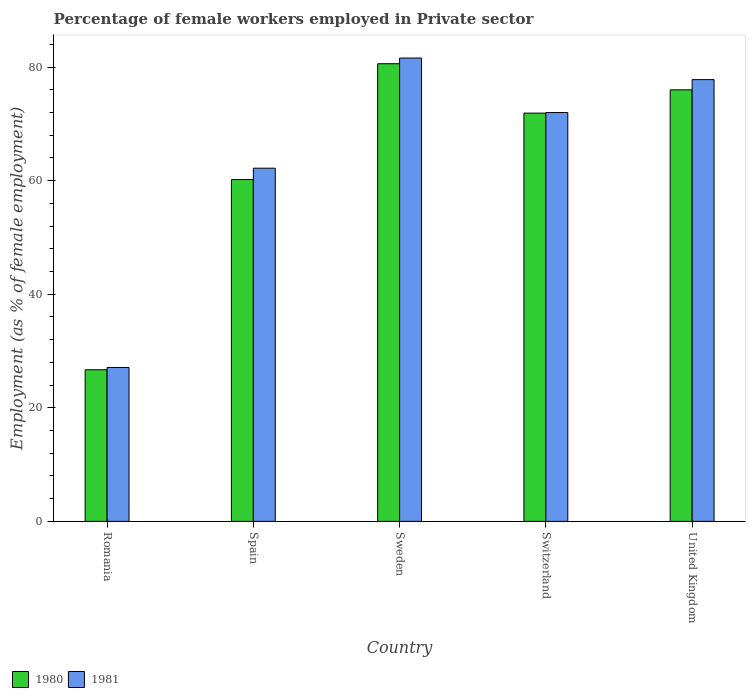How many groups of bars are there?
Offer a very short reply. 5. Are the number of bars on each tick of the X-axis equal?
Give a very brief answer. Yes. What is the label of the 3rd group of bars from the left?
Your answer should be very brief. Sweden. Across all countries, what is the maximum percentage of females employed in Private sector in 1980?
Offer a very short reply. 80.6. Across all countries, what is the minimum percentage of females employed in Private sector in 1980?
Ensure brevity in your answer.  26.7. In which country was the percentage of females employed in Private sector in 1980 minimum?
Offer a very short reply. Romania. What is the total percentage of females employed in Private sector in 1980 in the graph?
Ensure brevity in your answer.  315.4. What is the difference between the percentage of females employed in Private sector in 1980 in Spain and that in United Kingdom?
Ensure brevity in your answer.  -15.8. What is the difference between the percentage of females employed in Private sector in 1980 in Sweden and the percentage of females employed in Private sector in 1981 in Switzerland?
Provide a short and direct response. 8.6. What is the average percentage of females employed in Private sector in 1980 per country?
Your response must be concise. 63.08. What is the difference between the percentage of females employed in Private sector of/in 1981 and percentage of females employed in Private sector of/in 1980 in Switzerland?
Keep it short and to the point. 0.1. What is the ratio of the percentage of females employed in Private sector in 1980 in Sweden to that in United Kingdom?
Provide a short and direct response. 1.06. Is the percentage of females employed in Private sector in 1980 in Romania less than that in Spain?
Your answer should be compact. Yes. Is the difference between the percentage of females employed in Private sector in 1981 in Romania and Switzerland greater than the difference between the percentage of females employed in Private sector in 1980 in Romania and Switzerland?
Your answer should be compact. Yes. What is the difference between the highest and the second highest percentage of females employed in Private sector in 1981?
Make the answer very short. -9.6. What is the difference between the highest and the lowest percentage of females employed in Private sector in 1980?
Your answer should be very brief. 53.9. Is the sum of the percentage of females employed in Private sector in 1981 in Spain and United Kingdom greater than the maximum percentage of females employed in Private sector in 1980 across all countries?
Ensure brevity in your answer.  Yes. What does the 1st bar from the left in Spain represents?
Provide a short and direct response. 1980. What does the 1st bar from the right in Romania represents?
Offer a terse response. 1981. Are all the bars in the graph horizontal?
Your response must be concise. No. Does the graph contain grids?
Ensure brevity in your answer.  No. Where does the legend appear in the graph?
Provide a short and direct response. Bottom left. How are the legend labels stacked?
Offer a very short reply. Horizontal. What is the title of the graph?
Offer a terse response. Percentage of female workers employed in Private sector. What is the label or title of the Y-axis?
Offer a very short reply. Employment (as % of female employment). What is the Employment (as % of female employment) in 1980 in Romania?
Offer a terse response. 26.7. What is the Employment (as % of female employment) in 1981 in Romania?
Your answer should be very brief. 27.1. What is the Employment (as % of female employment) of 1980 in Spain?
Your response must be concise. 60.2. What is the Employment (as % of female employment) in 1981 in Spain?
Keep it short and to the point. 62.2. What is the Employment (as % of female employment) in 1980 in Sweden?
Provide a succinct answer. 80.6. What is the Employment (as % of female employment) in 1981 in Sweden?
Give a very brief answer. 81.6. What is the Employment (as % of female employment) in 1980 in Switzerland?
Your response must be concise. 71.9. What is the Employment (as % of female employment) in 1980 in United Kingdom?
Give a very brief answer. 76. What is the Employment (as % of female employment) of 1981 in United Kingdom?
Give a very brief answer. 77.8. Across all countries, what is the maximum Employment (as % of female employment) in 1980?
Your answer should be compact. 80.6. Across all countries, what is the maximum Employment (as % of female employment) in 1981?
Make the answer very short. 81.6. Across all countries, what is the minimum Employment (as % of female employment) in 1980?
Ensure brevity in your answer.  26.7. Across all countries, what is the minimum Employment (as % of female employment) of 1981?
Offer a very short reply. 27.1. What is the total Employment (as % of female employment) in 1980 in the graph?
Your answer should be compact. 315.4. What is the total Employment (as % of female employment) of 1981 in the graph?
Your answer should be compact. 320.7. What is the difference between the Employment (as % of female employment) of 1980 in Romania and that in Spain?
Keep it short and to the point. -33.5. What is the difference between the Employment (as % of female employment) in 1981 in Romania and that in Spain?
Ensure brevity in your answer.  -35.1. What is the difference between the Employment (as % of female employment) in 1980 in Romania and that in Sweden?
Offer a very short reply. -53.9. What is the difference between the Employment (as % of female employment) of 1981 in Romania and that in Sweden?
Provide a short and direct response. -54.5. What is the difference between the Employment (as % of female employment) of 1980 in Romania and that in Switzerland?
Offer a very short reply. -45.2. What is the difference between the Employment (as % of female employment) of 1981 in Romania and that in Switzerland?
Provide a succinct answer. -44.9. What is the difference between the Employment (as % of female employment) of 1980 in Romania and that in United Kingdom?
Keep it short and to the point. -49.3. What is the difference between the Employment (as % of female employment) in 1981 in Romania and that in United Kingdom?
Make the answer very short. -50.7. What is the difference between the Employment (as % of female employment) of 1980 in Spain and that in Sweden?
Give a very brief answer. -20.4. What is the difference between the Employment (as % of female employment) in 1981 in Spain and that in Sweden?
Your answer should be very brief. -19.4. What is the difference between the Employment (as % of female employment) of 1980 in Spain and that in United Kingdom?
Make the answer very short. -15.8. What is the difference between the Employment (as % of female employment) of 1981 in Spain and that in United Kingdom?
Ensure brevity in your answer.  -15.6. What is the difference between the Employment (as % of female employment) of 1981 in Sweden and that in Switzerland?
Offer a very short reply. 9.6. What is the difference between the Employment (as % of female employment) of 1980 in Sweden and that in United Kingdom?
Offer a very short reply. 4.6. What is the difference between the Employment (as % of female employment) of 1980 in Romania and the Employment (as % of female employment) of 1981 in Spain?
Your answer should be compact. -35.5. What is the difference between the Employment (as % of female employment) of 1980 in Romania and the Employment (as % of female employment) of 1981 in Sweden?
Keep it short and to the point. -54.9. What is the difference between the Employment (as % of female employment) in 1980 in Romania and the Employment (as % of female employment) in 1981 in Switzerland?
Provide a short and direct response. -45.3. What is the difference between the Employment (as % of female employment) of 1980 in Romania and the Employment (as % of female employment) of 1981 in United Kingdom?
Keep it short and to the point. -51.1. What is the difference between the Employment (as % of female employment) of 1980 in Spain and the Employment (as % of female employment) of 1981 in Sweden?
Keep it short and to the point. -21.4. What is the difference between the Employment (as % of female employment) in 1980 in Spain and the Employment (as % of female employment) in 1981 in Switzerland?
Offer a terse response. -11.8. What is the difference between the Employment (as % of female employment) of 1980 in Spain and the Employment (as % of female employment) of 1981 in United Kingdom?
Provide a short and direct response. -17.6. What is the difference between the Employment (as % of female employment) of 1980 in Switzerland and the Employment (as % of female employment) of 1981 in United Kingdom?
Your response must be concise. -5.9. What is the average Employment (as % of female employment) in 1980 per country?
Provide a succinct answer. 63.08. What is the average Employment (as % of female employment) of 1981 per country?
Offer a terse response. 64.14. What is the difference between the Employment (as % of female employment) in 1980 and Employment (as % of female employment) in 1981 in Romania?
Your response must be concise. -0.4. What is the difference between the Employment (as % of female employment) of 1980 and Employment (as % of female employment) of 1981 in Spain?
Make the answer very short. -2. What is the difference between the Employment (as % of female employment) of 1980 and Employment (as % of female employment) of 1981 in Sweden?
Your answer should be compact. -1. What is the difference between the Employment (as % of female employment) of 1980 and Employment (as % of female employment) of 1981 in Switzerland?
Your answer should be compact. -0.1. What is the ratio of the Employment (as % of female employment) in 1980 in Romania to that in Spain?
Offer a terse response. 0.44. What is the ratio of the Employment (as % of female employment) in 1981 in Romania to that in Spain?
Provide a short and direct response. 0.44. What is the ratio of the Employment (as % of female employment) in 1980 in Romania to that in Sweden?
Keep it short and to the point. 0.33. What is the ratio of the Employment (as % of female employment) in 1981 in Romania to that in Sweden?
Offer a very short reply. 0.33. What is the ratio of the Employment (as % of female employment) in 1980 in Romania to that in Switzerland?
Your response must be concise. 0.37. What is the ratio of the Employment (as % of female employment) in 1981 in Romania to that in Switzerland?
Your response must be concise. 0.38. What is the ratio of the Employment (as % of female employment) of 1980 in Romania to that in United Kingdom?
Provide a short and direct response. 0.35. What is the ratio of the Employment (as % of female employment) in 1981 in Romania to that in United Kingdom?
Your answer should be very brief. 0.35. What is the ratio of the Employment (as % of female employment) in 1980 in Spain to that in Sweden?
Your response must be concise. 0.75. What is the ratio of the Employment (as % of female employment) of 1981 in Spain to that in Sweden?
Provide a succinct answer. 0.76. What is the ratio of the Employment (as % of female employment) of 1980 in Spain to that in Switzerland?
Make the answer very short. 0.84. What is the ratio of the Employment (as % of female employment) in 1981 in Spain to that in Switzerland?
Provide a succinct answer. 0.86. What is the ratio of the Employment (as % of female employment) in 1980 in Spain to that in United Kingdom?
Ensure brevity in your answer.  0.79. What is the ratio of the Employment (as % of female employment) of 1981 in Spain to that in United Kingdom?
Give a very brief answer. 0.8. What is the ratio of the Employment (as % of female employment) in 1980 in Sweden to that in Switzerland?
Give a very brief answer. 1.12. What is the ratio of the Employment (as % of female employment) in 1981 in Sweden to that in Switzerland?
Your answer should be compact. 1.13. What is the ratio of the Employment (as % of female employment) of 1980 in Sweden to that in United Kingdom?
Your answer should be compact. 1.06. What is the ratio of the Employment (as % of female employment) in 1981 in Sweden to that in United Kingdom?
Make the answer very short. 1.05. What is the ratio of the Employment (as % of female employment) in 1980 in Switzerland to that in United Kingdom?
Make the answer very short. 0.95. What is the ratio of the Employment (as % of female employment) of 1981 in Switzerland to that in United Kingdom?
Provide a short and direct response. 0.93. What is the difference between the highest and the lowest Employment (as % of female employment) of 1980?
Ensure brevity in your answer.  53.9. What is the difference between the highest and the lowest Employment (as % of female employment) in 1981?
Your answer should be very brief. 54.5. 